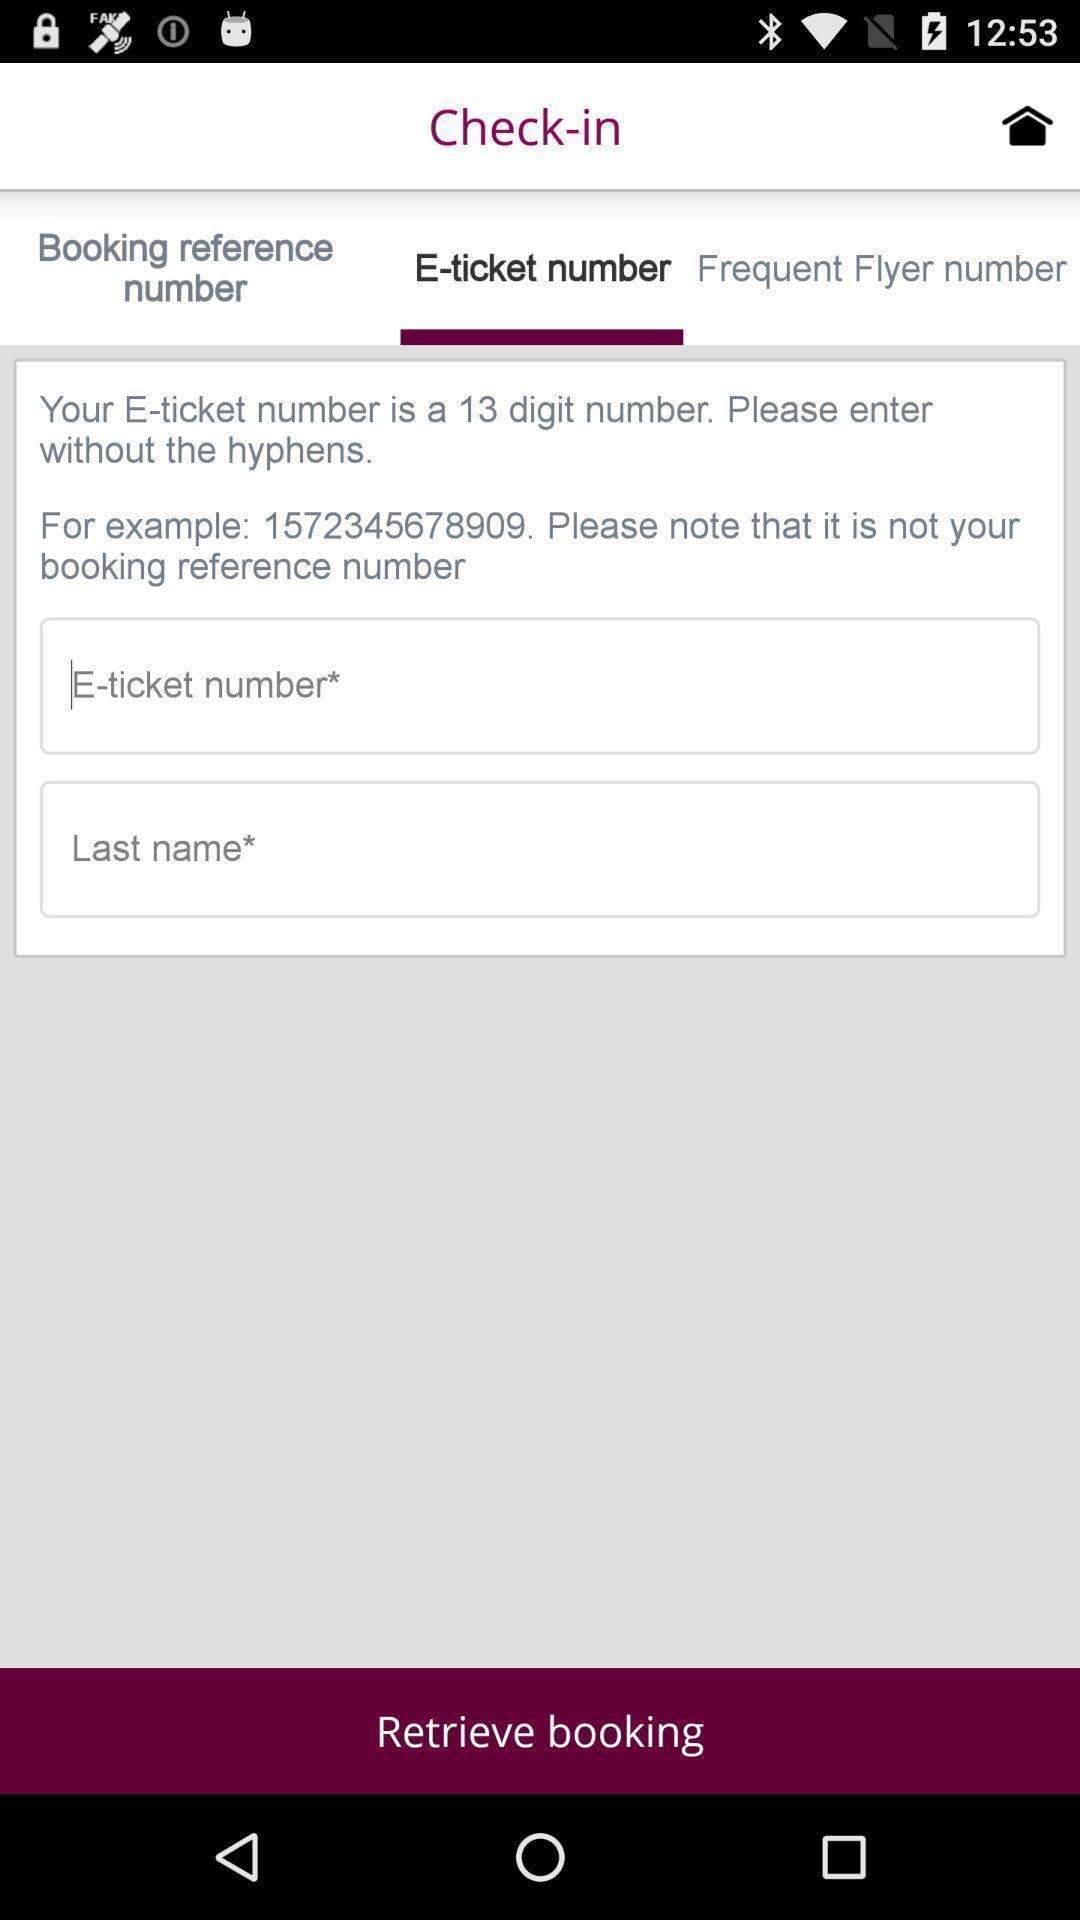What can you discern from this picture? Page asking to enter check-in details in app. 